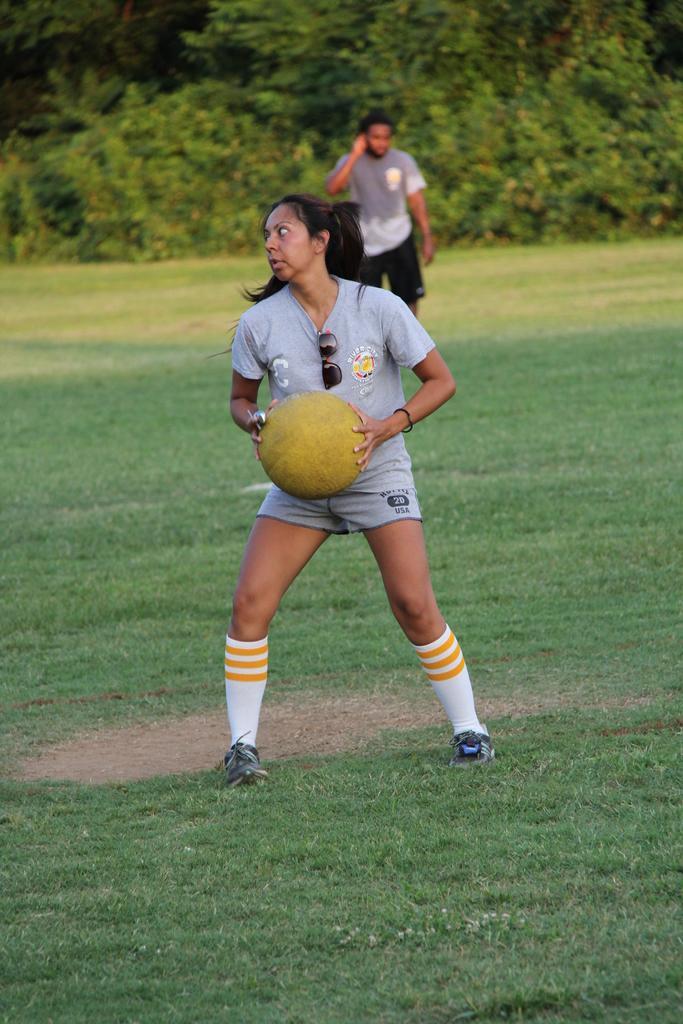Can you describe this image briefly? in this picture we see a woman holding a ball in her hand and we see a man on the back and trees around 